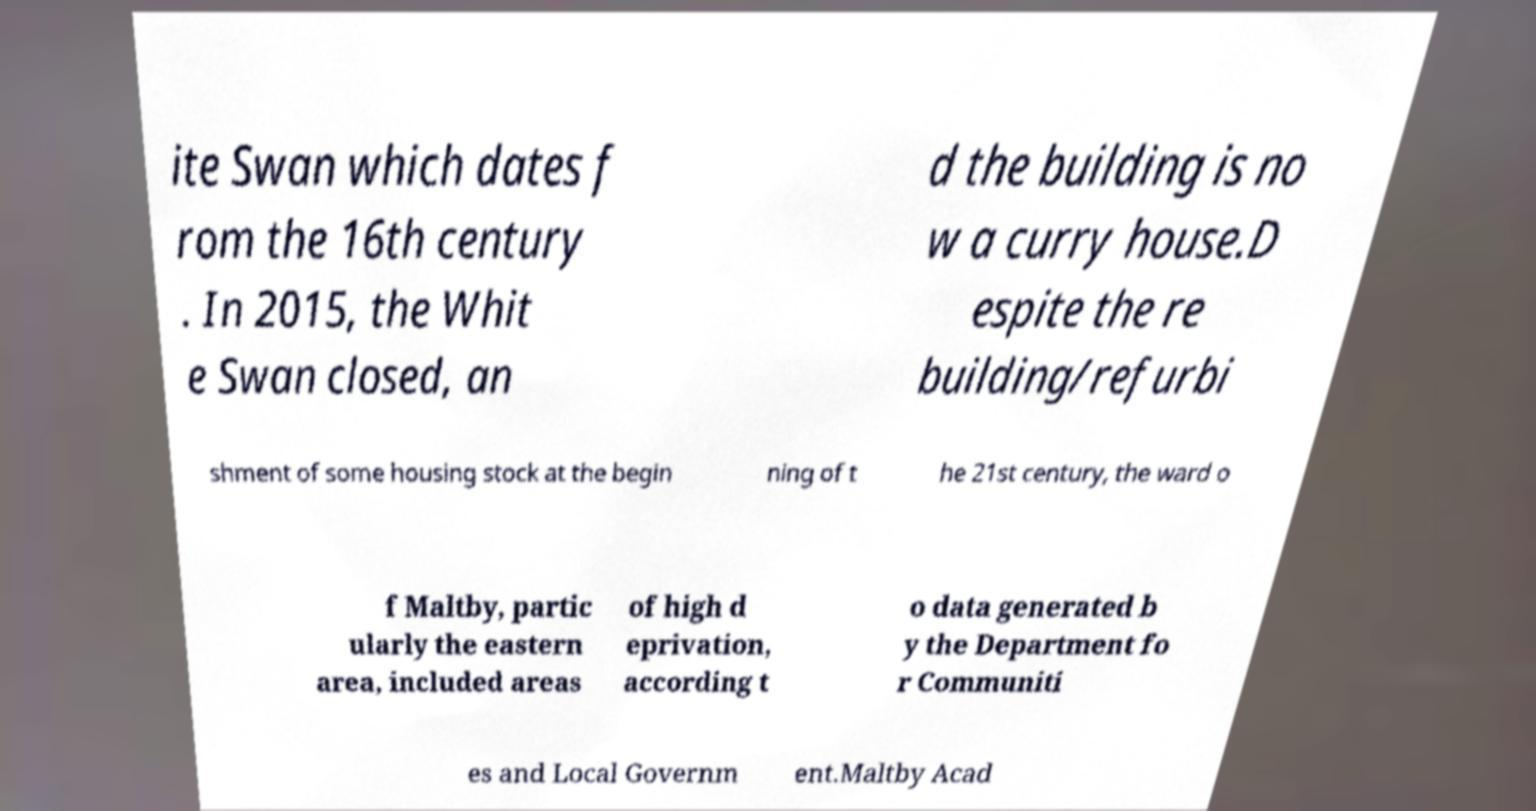There's text embedded in this image that I need extracted. Can you transcribe it verbatim? ite Swan which dates f rom the 16th century . In 2015, the Whit e Swan closed, an d the building is no w a curry house.D espite the re building/refurbi shment of some housing stock at the begin ning of t he 21st century, the ward o f Maltby, partic ularly the eastern area, included areas of high d eprivation, according t o data generated b y the Department fo r Communiti es and Local Governm ent.Maltby Acad 